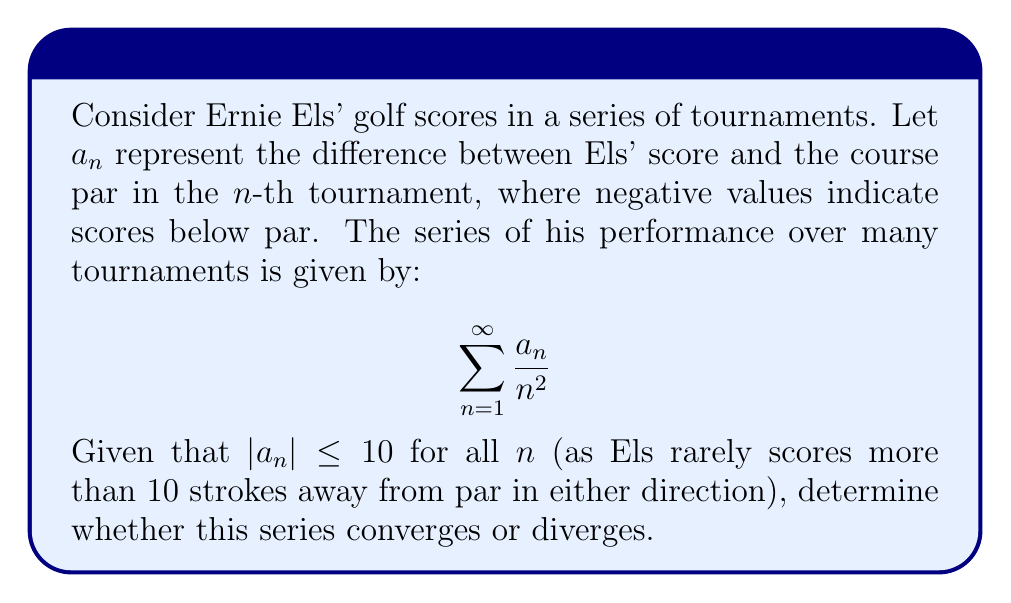Provide a solution to this math problem. To determine the convergence of this series, we can use the comparison test:

1) We know that $|a_n| \leq 10$ for all $n$. Therefore:

   $$\left|\frac{a_n}{n^2}\right| \leq \frac{10}{n^2}$$

2) Consider the series $\sum_{n=1}^{\infty} \frac{10}{n^2}$. This is a constant multiple of the p-series $\sum_{n=1}^{\infty} \frac{1}{n^2}$.

3) We know that the p-series $\sum_{n=1}^{\infty} \frac{1}{n^p}$ converges for $p > 1$. In this case, $p = 2 > 1$.

4) Therefore, $\sum_{n=1}^{\infty} \frac{10}{n^2}$ converges.

5) By the comparison test, if $\sum_{n=1}^{\infty} \frac{10}{n^2}$ converges, and $\left|\frac{a_n}{n^2}\right| \leq \frac{10}{n^2}$ for all $n$, then $\sum_{n=1}^{\infty} \frac{a_n}{n^2}$ also converges.

Thus, the series representing Ernie Els' golf scores over multiple tournaments converges.
Answer: The series converges. 